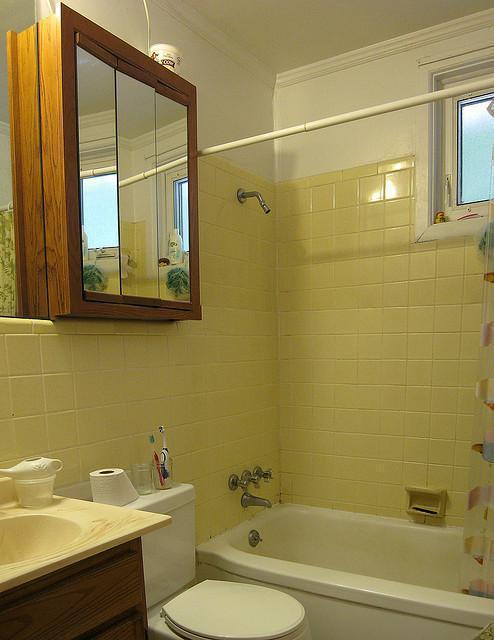What happens behind the curtain?
Answer the question by selecting the correct answer among the 4 following choices.
Options: Eating, sleeping, movie time, cleaning. Cleaning. Why is the toilet paper on the toilet tank?
Choose the right answer and clarify with the format: 'Answer: answer
Rationale: rationale.'
Options: Bidet, decoration, no holder, forgotten. Answer: no holder.
Rationale: There is a roll of toilet paper on the toilet tank because there is not a toilet paper holder in the bathroom. 